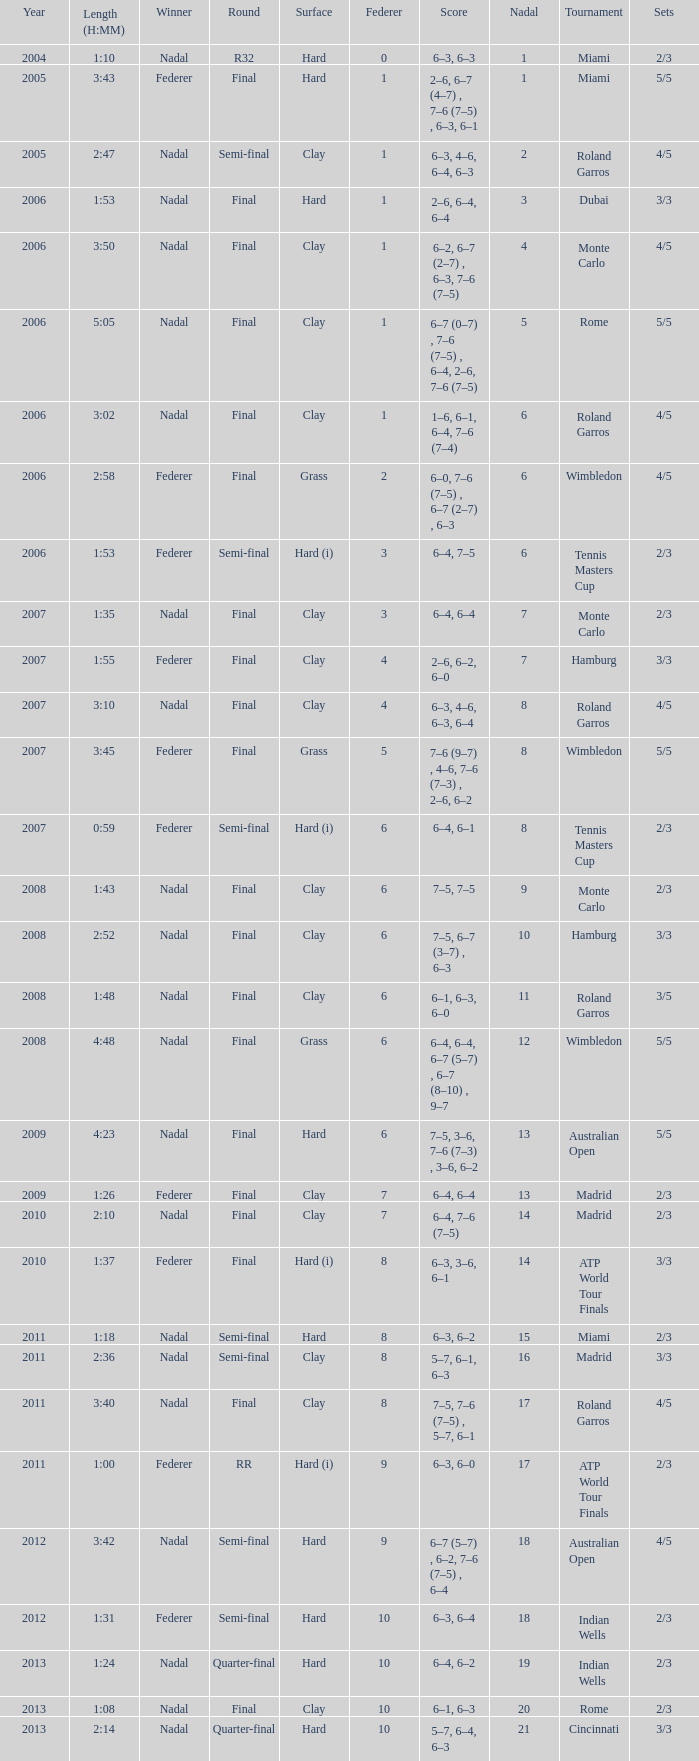What were the sets when Federer had 6 and a nadal of 13? 5/5. I'm looking to parse the entire table for insights. Could you assist me with that? {'header': ['Year', 'Length (H:MM)', 'Winner', 'Round', 'Surface', 'Federer', 'Score', 'Nadal', 'Tournament', 'Sets'], 'rows': [['2004', '1:10', 'Nadal', 'R32', 'Hard', '0', '6–3, 6–3', '1', 'Miami', '2/3'], ['2005', '3:43', 'Federer', 'Final', 'Hard', '1', '2–6, 6–7 (4–7) , 7–6 (7–5) , 6–3, 6–1', '1', 'Miami', '5/5'], ['2005', '2:47', 'Nadal', 'Semi-final', 'Clay', '1', '6–3, 4–6, 6–4, 6–3', '2', 'Roland Garros', '4/5'], ['2006', '1:53', 'Nadal', 'Final', 'Hard', '1', '2–6, 6–4, 6–4', '3', 'Dubai', '3/3'], ['2006', '3:50', 'Nadal', 'Final', 'Clay', '1', '6–2, 6–7 (2–7) , 6–3, 7–6 (7–5)', '4', 'Monte Carlo', '4/5'], ['2006', '5:05', 'Nadal', 'Final', 'Clay', '1', '6–7 (0–7) , 7–6 (7–5) , 6–4, 2–6, 7–6 (7–5)', '5', 'Rome', '5/5'], ['2006', '3:02', 'Nadal', 'Final', 'Clay', '1', '1–6, 6–1, 6–4, 7–6 (7–4)', '6', 'Roland Garros', '4/5'], ['2006', '2:58', 'Federer', 'Final', 'Grass', '2', '6–0, 7–6 (7–5) , 6–7 (2–7) , 6–3', '6', 'Wimbledon', '4/5'], ['2006', '1:53', 'Federer', 'Semi-final', 'Hard (i)', '3', '6–4, 7–5', '6', 'Tennis Masters Cup', '2/3'], ['2007', '1:35', 'Nadal', 'Final', 'Clay', '3', '6–4, 6–4', '7', 'Monte Carlo', '2/3'], ['2007', '1:55', 'Federer', 'Final', 'Clay', '4', '2–6, 6–2, 6–0', '7', 'Hamburg', '3/3'], ['2007', '3:10', 'Nadal', 'Final', 'Clay', '4', '6–3, 4–6, 6–3, 6–4', '8', 'Roland Garros', '4/5'], ['2007', '3:45', 'Federer', 'Final', 'Grass', '5', '7–6 (9–7) , 4–6, 7–6 (7–3) , 2–6, 6–2', '8', 'Wimbledon', '5/5'], ['2007', '0:59', 'Federer', 'Semi-final', 'Hard (i)', '6', '6–4, 6–1', '8', 'Tennis Masters Cup', '2/3'], ['2008', '1:43', 'Nadal', 'Final', 'Clay', '6', '7–5, 7–5', '9', 'Monte Carlo', '2/3'], ['2008', '2:52', 'Nadal', 'Final', 'Clay', '6', '7–5, 6–7 (3–7) , 6–3', '10', 'Hamburg', '3/3'], ['2008', '1:48', 'Nadal', 'Final', 'Clay', '6', '6–1, 6–3, 6–0', '11', 'Roland Garros', '3/5'], ['2008', '4:48', 'Nadal', 'Final', 'Grass', '6', '6–4, 6–4, 6–7 (5–7) , 6–7 (8–10) , 9–7', '12', 'Wimbledon', '5/5'], ['2009', '4:23', 'Nadal', 'Final', 'Hard', '6', '7–5, 3–6, 7–6 (7–3) , 3–6, 6–2', '13', 'Australian Open', '5/5'], ['2009', '1:26', 'Federer', 'Final', 'Clay', '7', '6–4, 6–4', '13', 'Madrid', '2/3'], ['2010', '2:10', 'Nadal', 'Final', 'Clay', '7', '6–4, 7–6 (7–5)', '14', 'Madrid', '2/3'], ['2010', '1:37', 'Federer', 'Final', 'Hard (i)', '8', '6–3, 3–6, 6–1', '14', 'ATP World Tour Finals', '3/3'], ['2011', '1:18', 'Nadal', 'Semi-final', 'Hard', '8', '6–3, 6–2', '15', 'Miami', '2/3'], ['2011', '2:36', 'Nadal', 'Semi-final', 'Clay', '8', '5–7, 6–1, 6–3', '16', 'Madrid', '3/3'], ['2011', '3:40', 'Nadal', 'Final', 'Clay', '8', '7–5, 7–6 (7–5) , 5–7, 6–1', '17', 'Roland Garros', '4/5'], ['2011', '1:00', 'Federer', 'RR', 'Hard (i)', '9', '6–3, 6–0', '17', 'ATP World Tour Finals', '2/3'], ['2012', '3:42', 'Nadal', 'Semi-final', 'Hard', '9', '6–7 (5–7) , 6–2, 7–6 (7–5) , 6–4', '18', 'Australian Open', '4/5'], ['2012', '1:31', 'Federer', 'Semi-final', 'Hard', '10', '6–3, 6–4', '18', 'Indian Wells', '2/3'], ['2013', '1:24', 'Nadal', 'Quarter-final', 'Hard', '10', '6–4, 6–2', '19', 'Indian Wells', '2/3'], ['2013', '1:08', 'Nadal', 'Final', 'Clay', '10', '6–1, 6–3', '20', 'Rome', '2/3'], ['2013', '2:14', 'Nadal', 'Quarter-final', 'Hard', '10', '5–7, 6–4, 6–3', '21', 'Cincinnati', '3/3']]} 